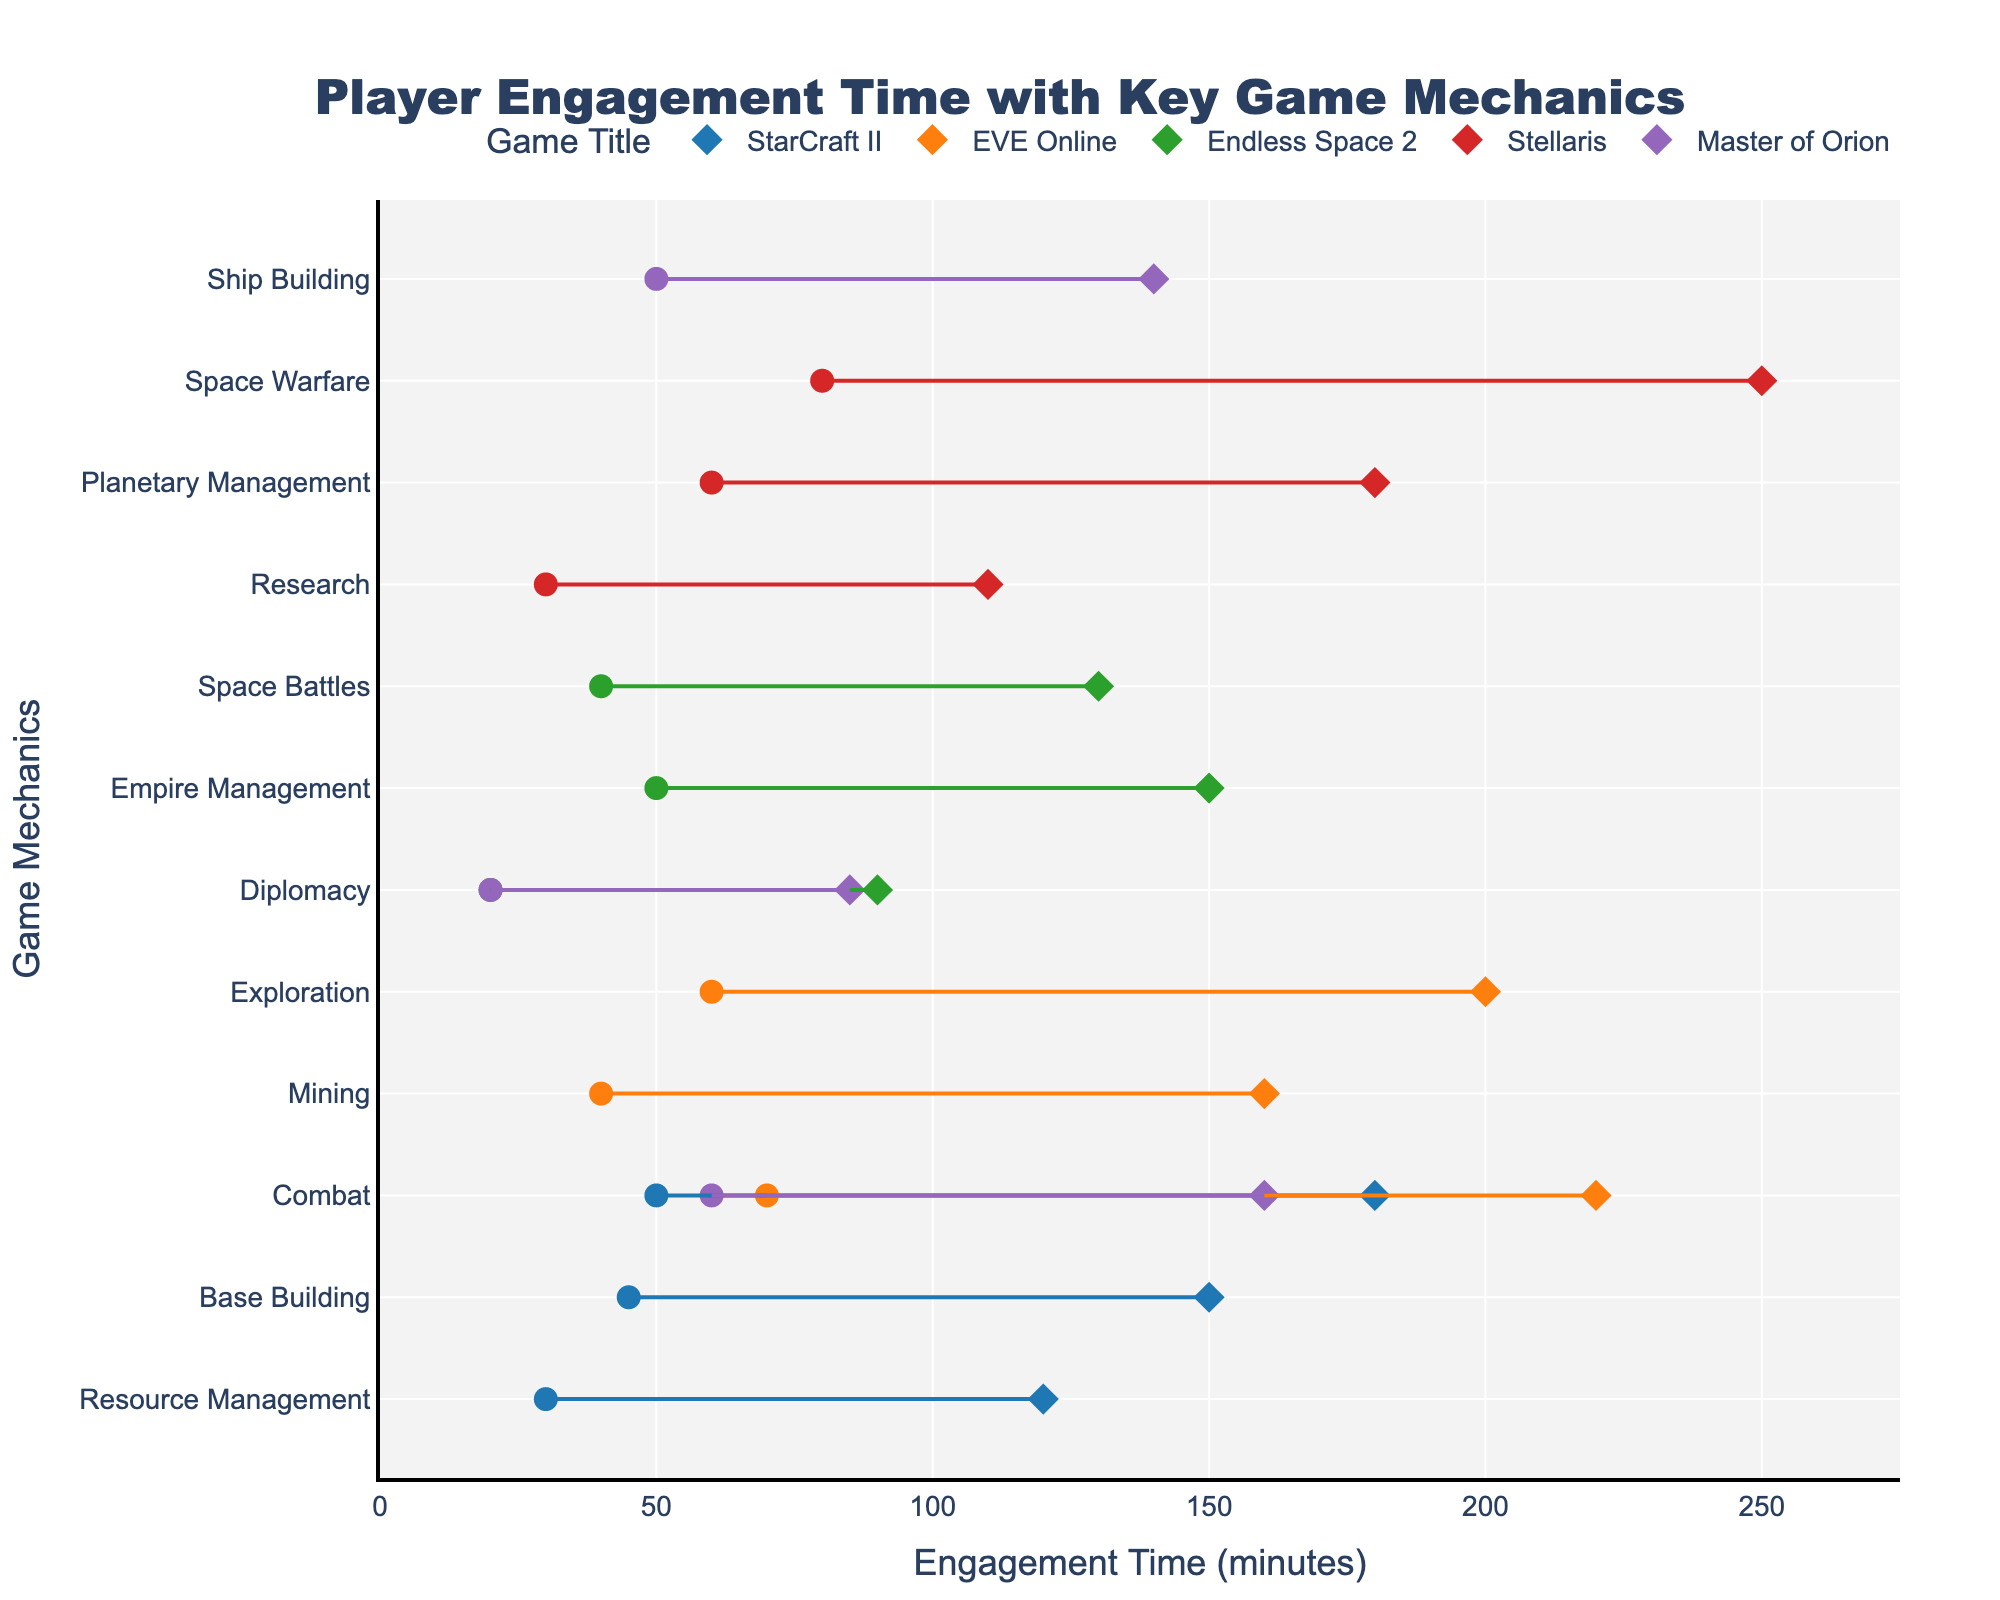What is the title of the plot? The title is written in the largest font at the top of the plot. It reads "Player Engagement Time with Key Game Mechanics".
Answer: Player Engagement Time with Key Game Mechanics What is the range of engagement time for 'Combat' in 'StarCraft II'? 'StarCraft II' has a line for 'Combat' stretching from 50 minutes to 180 minutes on the x-axis.
Answer: 50 to 180 minutes How many game mechanics are analyzed for 'Stellaris'? For 'Stellaris', different mechanics listed are 'Research', 'Planetary Management', and 'Space Warfare'. These are three mechanics.
Answer: 3 Which game title has the largest maximum engagement time and what is it? By examining the x-axis endpoints, 'Stellaris' has the highest engagement time of 250 minutes for 'Space Warfare'.
Answer: Stellaris, 250 minutes Which game mechanic in 'EVE Online' shows the highest minimum engagement time? 'EVE Online' has three mechanics: 'Mining' (40 minutes), 'Exploration' (60 minutes), and 'Combat' (70 minutes). The highest minimum engagement time is for 'Combat' at 70 minutes.
Answer: Combat Compare the range of engagement times for 'Base Building' in 'StarCraft II' and 'Ship Building' in 'Master of Orion'. Which one has a larger range? 'Base Building' in 'StarCraft II' ranges from 45 to 150 minutes, giving a range of 105 minutes. 'Ship Building' in 'Master of Orion' ranges from 50 to 140 minutes, giving a range of 90 minutes. 'Base Building' has a larger range.
Answer: Base Building Which game has the smallest range for any game mechanic and what is the mechanic? By analyzing the length of lines, 'Master of Orion' has the smallest range for 'Diplomacy', which spans from 20 to 85 minutes (65 minutes).
Answer: Master of Orion, Diplomacy 